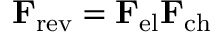Convert formula to latex. <formula><loc_0><loc_0><loc_500><loc_500>F _ { r e v } = F _ { e l } F _ { c h }</formula> 